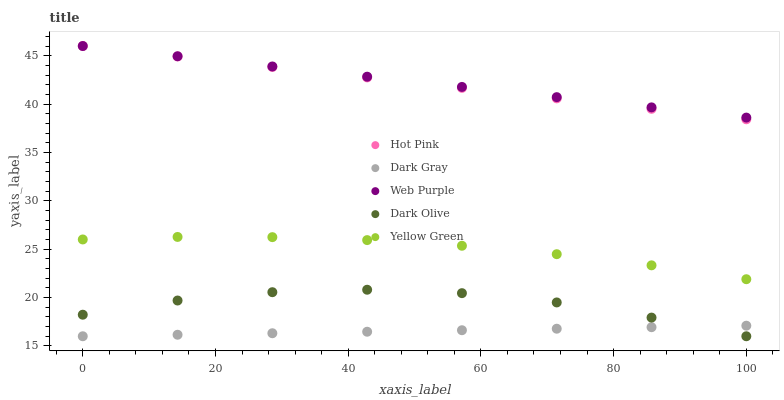Does Dark Gray have the minimum area under the curve?
Answer yes or no. Yes. Does Web Purple have the maximum area under the curve?
Answer yes or no. Yes. Does Hot Pink have the minimum area under the curve?
Answer yes or no. No. Does Hot Pink have the maximum area under the curve?
Answer yes or no. No. Is Dark Gray the smoothest?
Answer yes or no. Yes. Is Dark Olive the roughest?
Answer yes or no. Yes. Is Web Purple the smoothest?
Answer yes or no. No. Is Web Purple the roughest?
Answer yes or no. No. Does Dark Gray have the lowest value?
Answer yes or no. Yes. Does Hot Pink have the lowest value?
Answer yes or no. No. Does Hot Pink have the highest value?
Answer yes or no. Yes. Does Dark Olive have the highest value?
Answer yes or no. No. Is Dark Gray less than Yellow Green?
Answer yes or no. Yes. Is Hot Pink greater than Dark Gray?
Answer yes or no. Yes. Does Hot Pink intersect Web Purple?
Answer yes or no. Yes. Is Hot Pink less than Web Purple?
Answer yes or no. No. Is Hot Pink greater than Web Purple?
Answer yes or no. No. Does Dark Gray intersect Yellow Green?
Answer yes or no. No. 